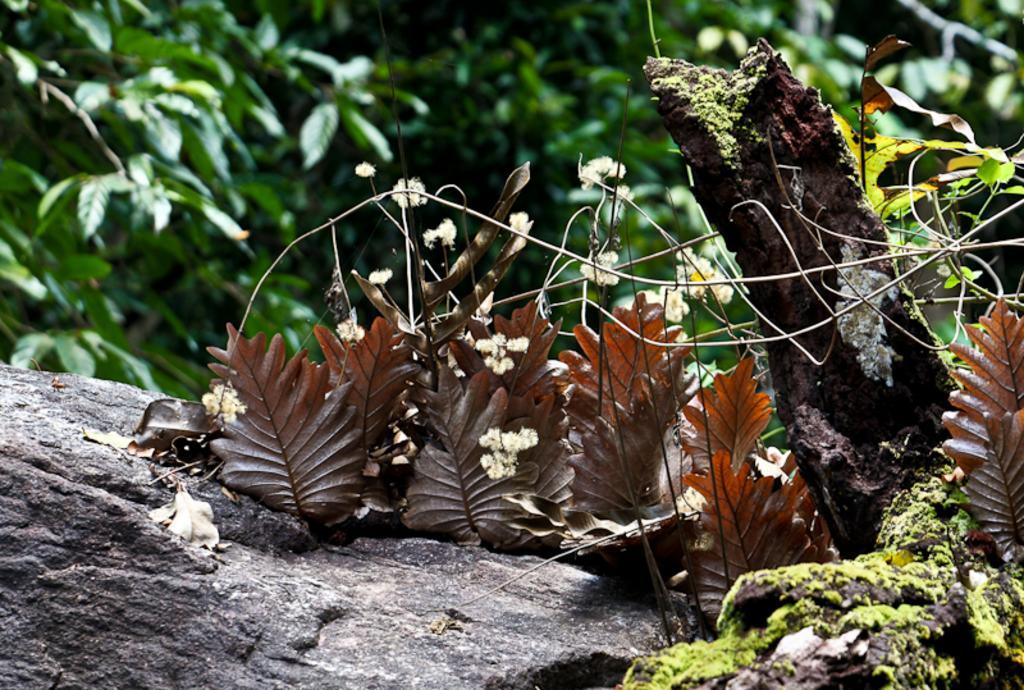Can you describe this image briefly? In this image we can see trees, there are dried leaves on a rock, beside there is a bark. 